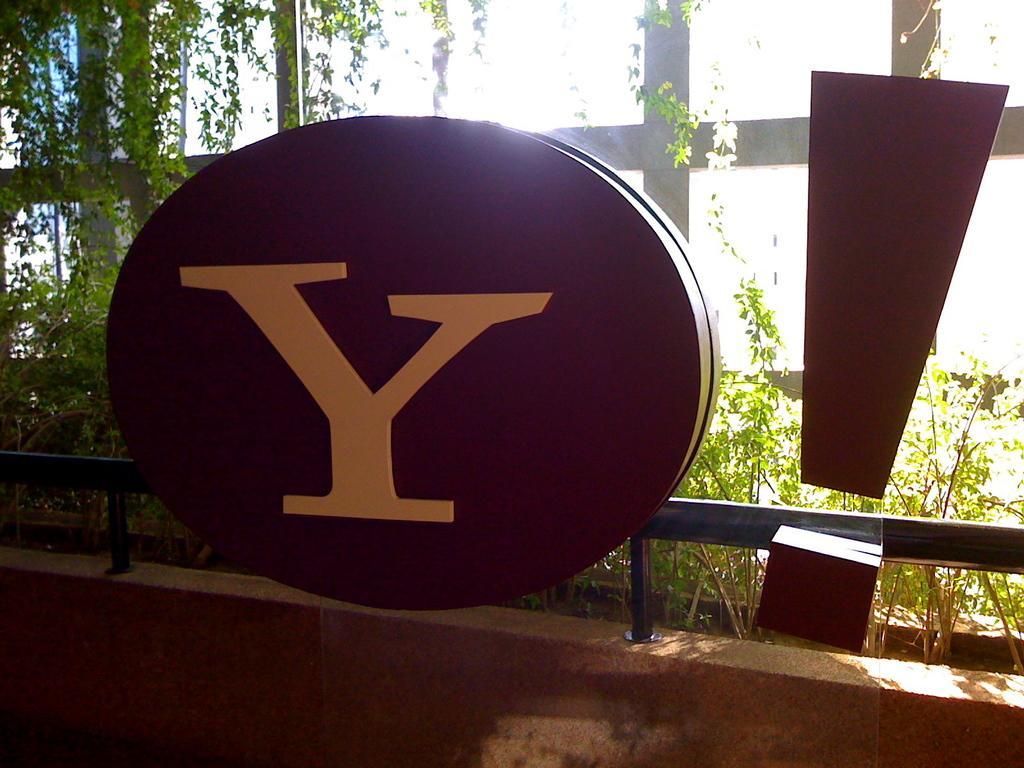Can you describe this image briefly? In this picture there are boards in the foreground and there is an alphabet on the board. At the back there are plants and there is a railing on the wall. 